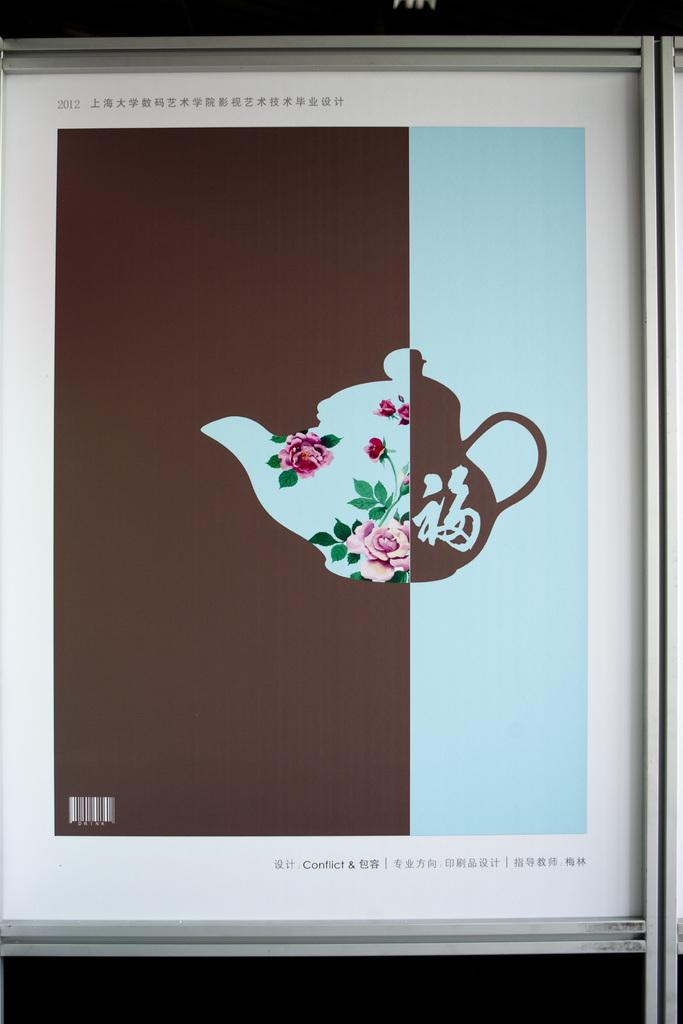<image>
Give a short and clear explanation of the subsequent image. A two tone piece of artwork called Conflict. 